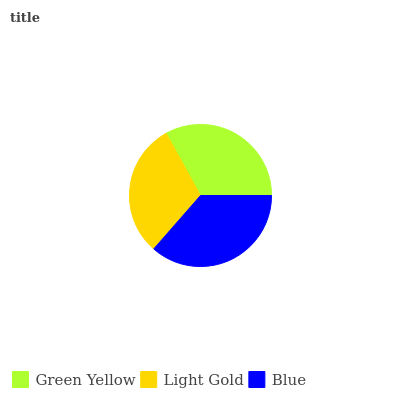Is Light Gold the minimum?
Answer yes or no. Yes. Is Blue the maximum?
Answer yes or no. Yes. Is Blue the minimum?
Answer yes or no. No. Is Light Gold the maximum?
Answer yes or no. No. Is Blue greater than Light Gold?
Answer yes or no. Yes. Is Light Gold less than Blue?
Answer yes or no. Yes. Is Light Gold greater than Blue?
Answer yes or no. No. Is Blue less than Light Gold?
Answer yes or no. No. Is Green Yellow the high median?
Answer yes or no. Yes. Is Green Yellow the low median?
Answer yes or no. Yes. Is Blue the high median?
Answer yes or no. No. Is Light Gold the low median?
Answer yes or no. No. 